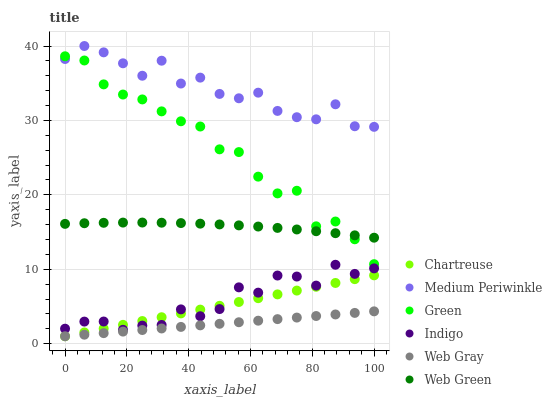Does Web Gray have the minimum area under the curve?
Answer yes or no. Yes. Does Medium Periwinkle have the maximum area under the curve?
Answer yes or no. Yes. Does Indigo have the minimum area under the curve?
Answer yes or no. No. Does Indigo have the maximum area under the curve?
Answer yes or no. No. Is Web Gray the smoothest?
Answer yes or no. Yes. Is Medium Periwinkle the roughest?
Answer yes or no. Yes. Is Indigo the smoothest?
Answer yes or no. No. Is Indigo the roughest?
Answer yes or no. No. Does Web Gray have the lowest value?
Answer yes or no. Yes. Does Indigo have the lowest value?
Answer yes or no. No. Does Medium Periwinkle have the highest value?
Answer yes or no. Yes. Does Indigo have the highest value?
Answer yes or no. No. Is Chartreuse less than Medium Periwinkle?
Answer yes or no. Yes. Is Green greater than Indigo?
Answer yes or no. Yes. Does Web Gray intersect Chartreuse?
Answer yes or no. Yes. Is Web Gray less than Chartreuse?
Answer yes or no. No. Is Web Gray greater than Chartreuse?
Answer yes or no. No. Does Chartreuse intersect Medium Periwinkle?
Answer yes or no. No. 